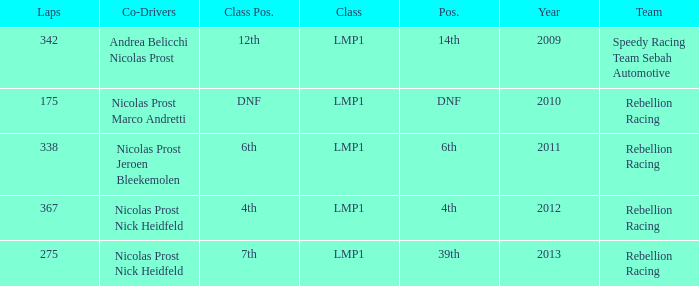What was the class position of the team that was in the 4th position? 4th. 